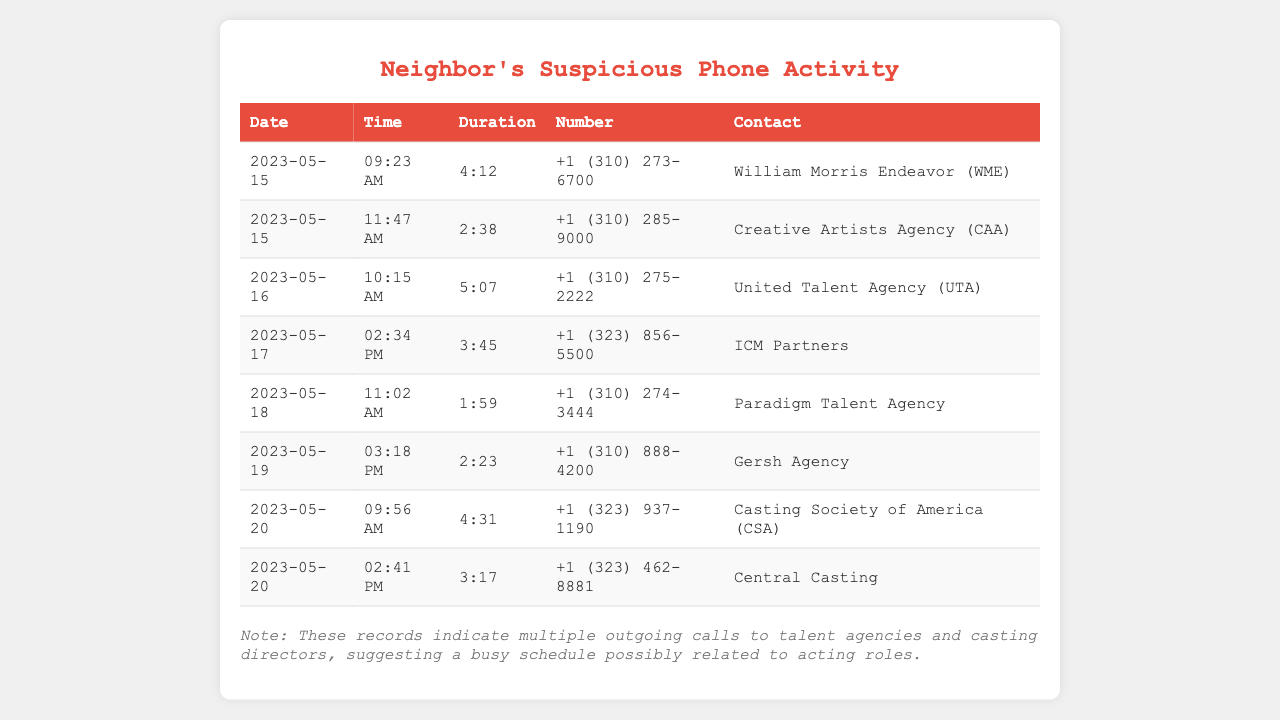What is the first agency called? The first agency listed in the records is the one contacted on May 15, which is William Morris Endeavor (WME).
Answer: William Morris Endeavor (WME) How many calls were made on May 20? Two calls were made on May 20 as seen in the table.
Answer: 2 What was the duration of the call to ICM Partners? The call duration to ICM Partners on May 17 was listed in the table.
Answer: 3:45 Which agency was contacted at 11:02 AM on May 18? The call at that time on May 18 was to Paradigm Talent Agency, as indicated in the document.
Answer: Paradigm Talent Agency What is the total number of outgoing calls recorded? By counting the entries in the table, we can confirm there are a total of 8 outgoing calls listed.
Answer: 8 What does the note at the end of the document imply? The note suggests that the actor’s frequent calls to agencies indicate they're likely busy with acting roles.
Answer: Busy schedule What is the contact number for Creative Artists Agency? The contact number for Creative Artists Agency is specified in the records.
Answer: +1 (310) 285-9000 What time did the actor make the call to Central Casting? The call to Central Casting is recorded at 2:41 PM on May 20.
Answer: 2:41 PM 